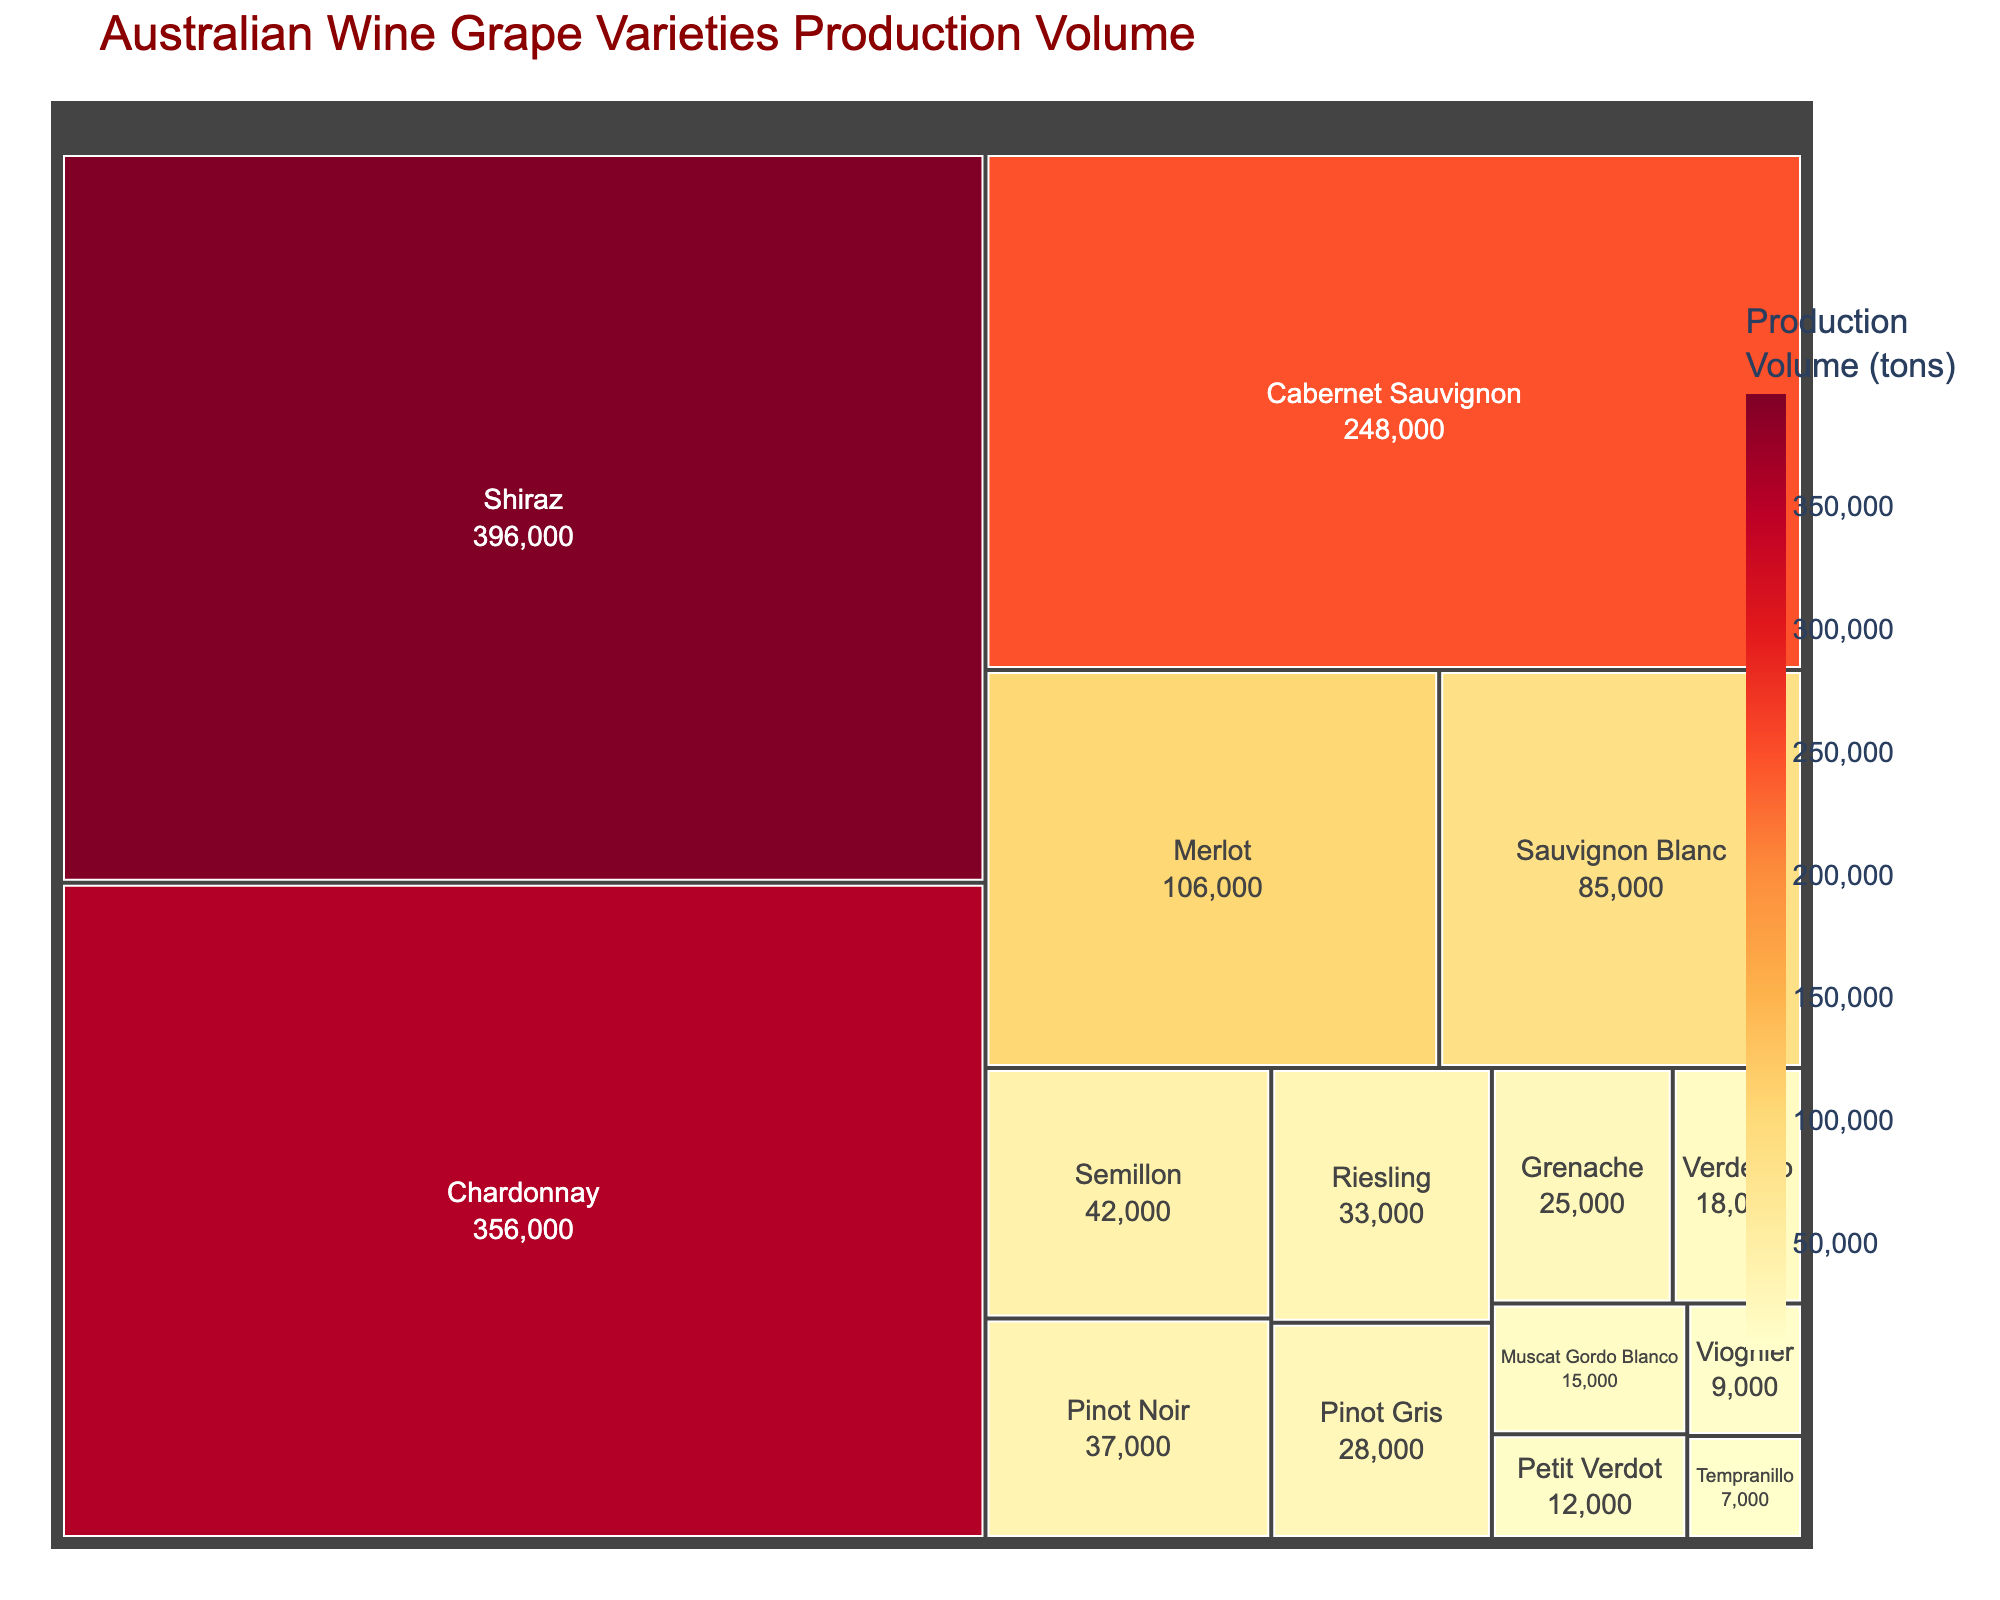what is the total production volume of Shiraz? The area representing Shiraz grapes in the treemap is labeled with its production volume. By looking at that part of the figure, the production volume of Shiraz is the value shown
Answer: 396,000 tons How many grape varieties have a production volume of less than 50,000 tons? By identifying and counting the areas in the treemap with labels indicating production volumes below 50,000 tons
Answer: 7 varieties What is the combined production volume of Cabernet Sauvignon and Merlot? Locate the areas representing Cabernet Sauvignon and Merlot in the treemap, note their production volumes, and sum them up: 248,000 + 106,000
Answer: 354,000 tons Which grape variety has the lowest production volume in the treemap? Find the smallest area with the smallest numerical label representing production volume in the figure
Answer: Tempranillo What is the average production volume of the top three grape varieties by production volume? Identify the top three grape varieties (Shiraz, Chardonnay, Cabernet Sauvignon), sum their production volumes, and divide by three: (396,000 + 356,000 + 248,000) / 3
Answer: 333,333.33 tons Is Chardonnay production greater than the combined production volumes of Pinot Noir and Sauvignon Blanc? Compare the production volume of Chardonnay (356,000) with the sum of Pinot Noir and Sauvignon Blanc (37,000 + 85,000 = 122,000)
Answer: Yes Which grape varieties have a production volume between 10,000 and 50,000 tons? Locate and list the areas whose labels indicate values within this range
Answer: Pinot Noir, Semillon, Riesling, Grenache, Verdelho, Muscat Gordo Blanco, Petit Verdot How does the production volume of Sauvignon Blanc compare to that of Pinot Gris? Compare the production volumes labeled for Sauvignon Blanc (85,000) and Pinot Gris (28,000) in the treemap
Answer: Higher What is the color scale used in the treemap representing the production volume? The treemap uses a color gradient to represent production volume. The specific colors can be identified as shades transitioning from light to dark
Answer: Shades from Yellow to Red (YlOrRd) By how much does the production volume of Shiraz exceed that of Viognier? Subtract the production volume of Viognier (9,000) from that of Shiraz (396,000)
Answer: 387,000 tons 